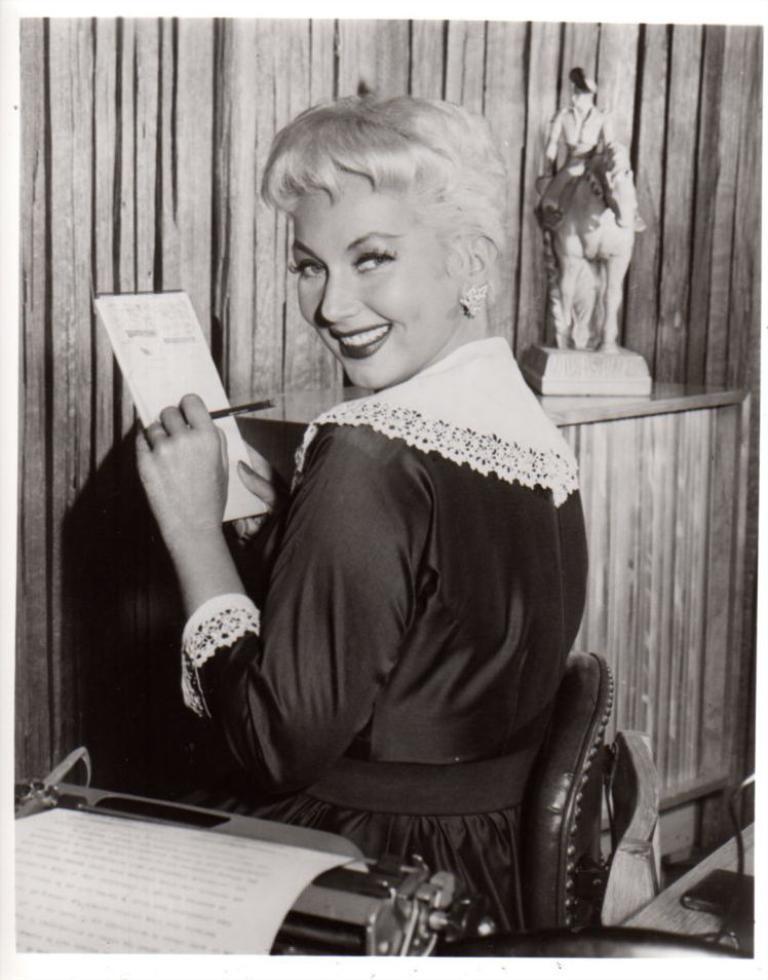Describe this image in one or two sentences. In this picture I can see a woman with a smile, holding a pen and a book. I can see the typewriter machine in the foreground. I can see the statue on the right side. I can see the wooden wall in the background. 